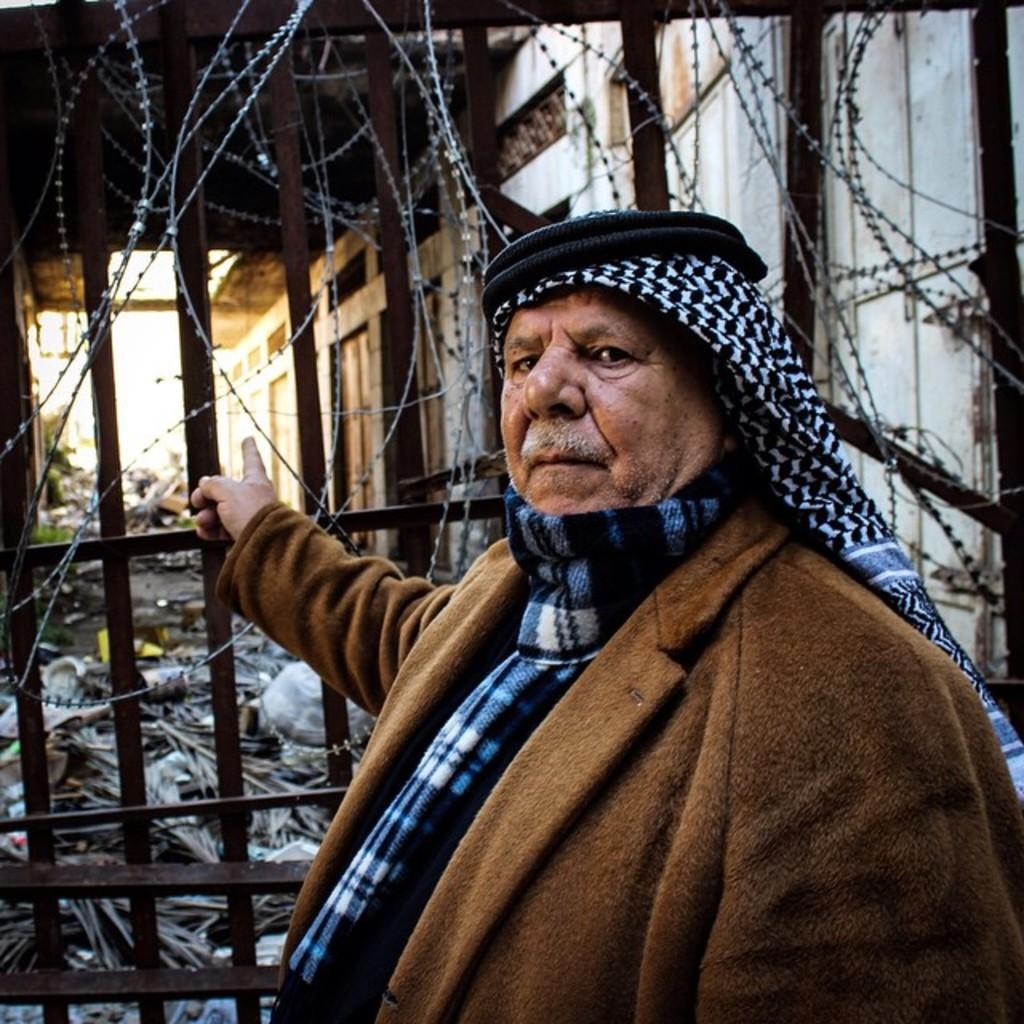Please provide a concise description of this image. In this picture we can see a person, behind we can see gate, fencing. 